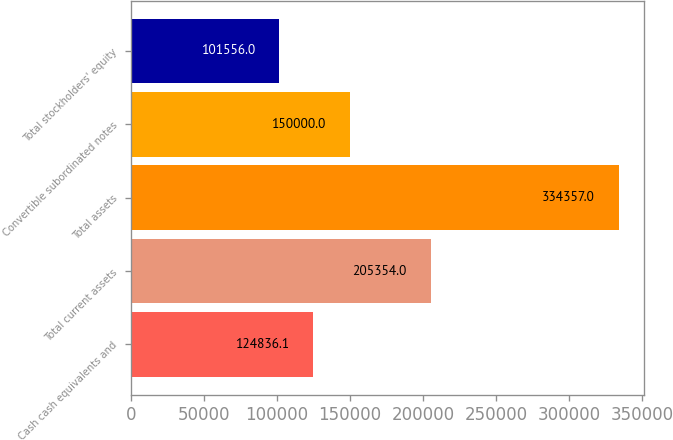Convert chart to OTSL. <chart><loc_0><loc_0><loc_500><loc_500><bar_chart><fcel>Cash cash equivalents and<fcel>Total current assets<fcel>Total assets<fcel>Convertible subordinated notes<fcel>Total stockholders' equity<nl><fcel>124836<fcel>205354<fcel>334357<fcel>150000<fcel>101556<nl></chart> 